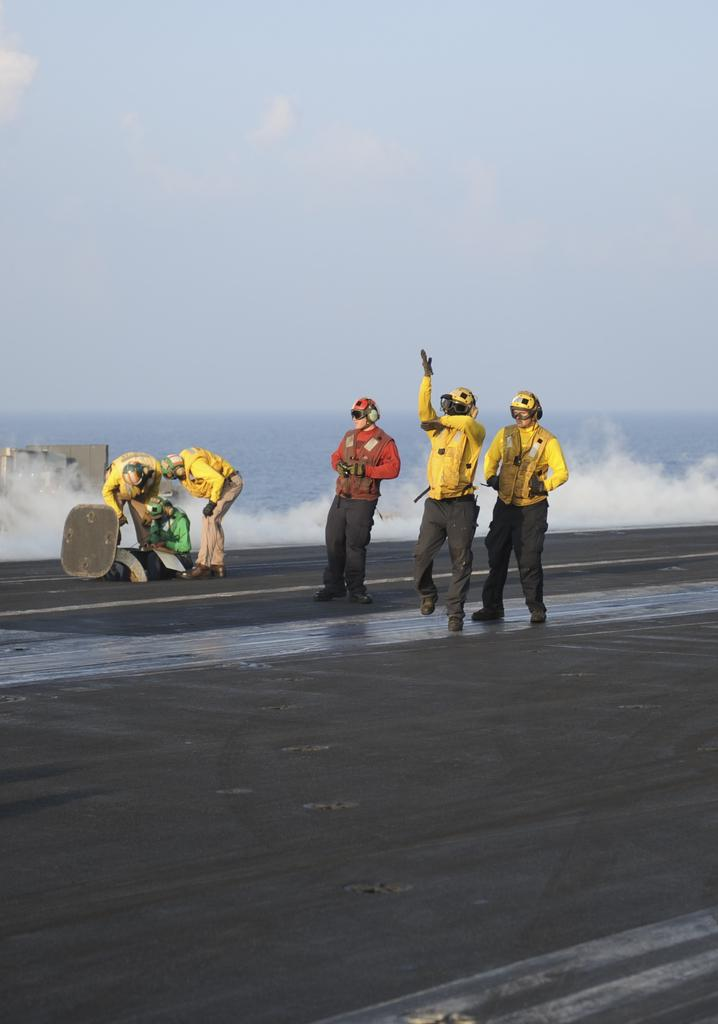How many people are in the image? There are people in the image, but the exact number is not specified. What are the people wearing on their heads? The people are wearing headphones in the image. What else are the people wearing? The people are also wearing helmets in the image. What is the position of the people in the image? The people are standing in the image. What can be seen in the background of the image? Water is visible in the background of the image. What is visible at the top of the image? The sky is visible at the top of the image. How many deer can be seen in the image? There are no deer present in the image. What type of engine is visible in the image? There is no engine present in the image. 